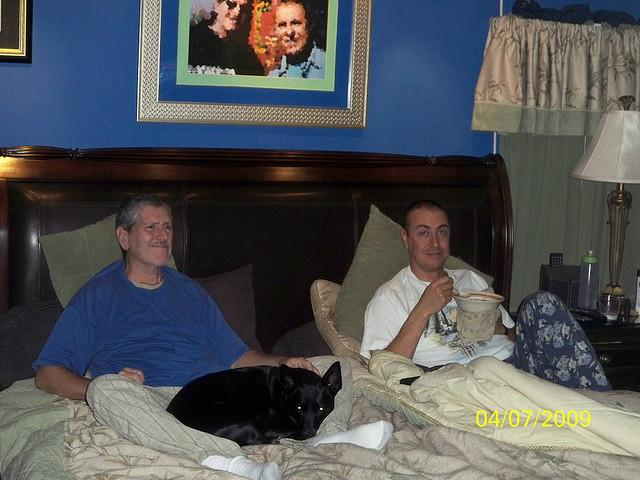How are these men related? father son 